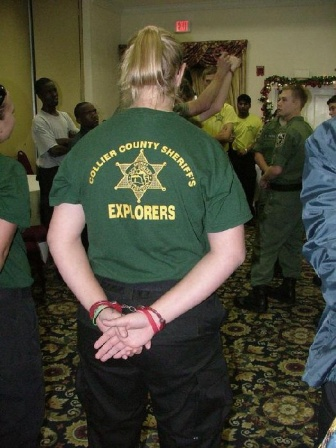Imagine a scenario where this image is part of a larger story involving a festive undercover operation. Describe it in detail. In a corner of a community center decked out with holiday decorations, an undercover operation is quietly unfolding. The 'Collier County Sheriff's Explorers,' known for their youth engagement programs, have gathered for what appears to be a typical holiday event. However, the person standing in the green t-shirt with 'Explorers' written on it is actually a seasoned detective in disguise. As she attentively watches over the room, she's monitoring a suspected exchange of counterfeit goods camouflaged as holiday gifts. Her casual stance with hands clasped behind her is a practiced pose to remain inconspicuous. Amidst the cheerful conversations and festive spirit, covert signals are exchanged among the officers posing as part of the gathering. Their mission: to apprehend the culprits without alarming the public. The beige walls and neutral carpeted floor of the room contrast with the tense undercurrent of the operation, highlighting the detective’s crucial role in ensuring the community's safety during the holiday season. 